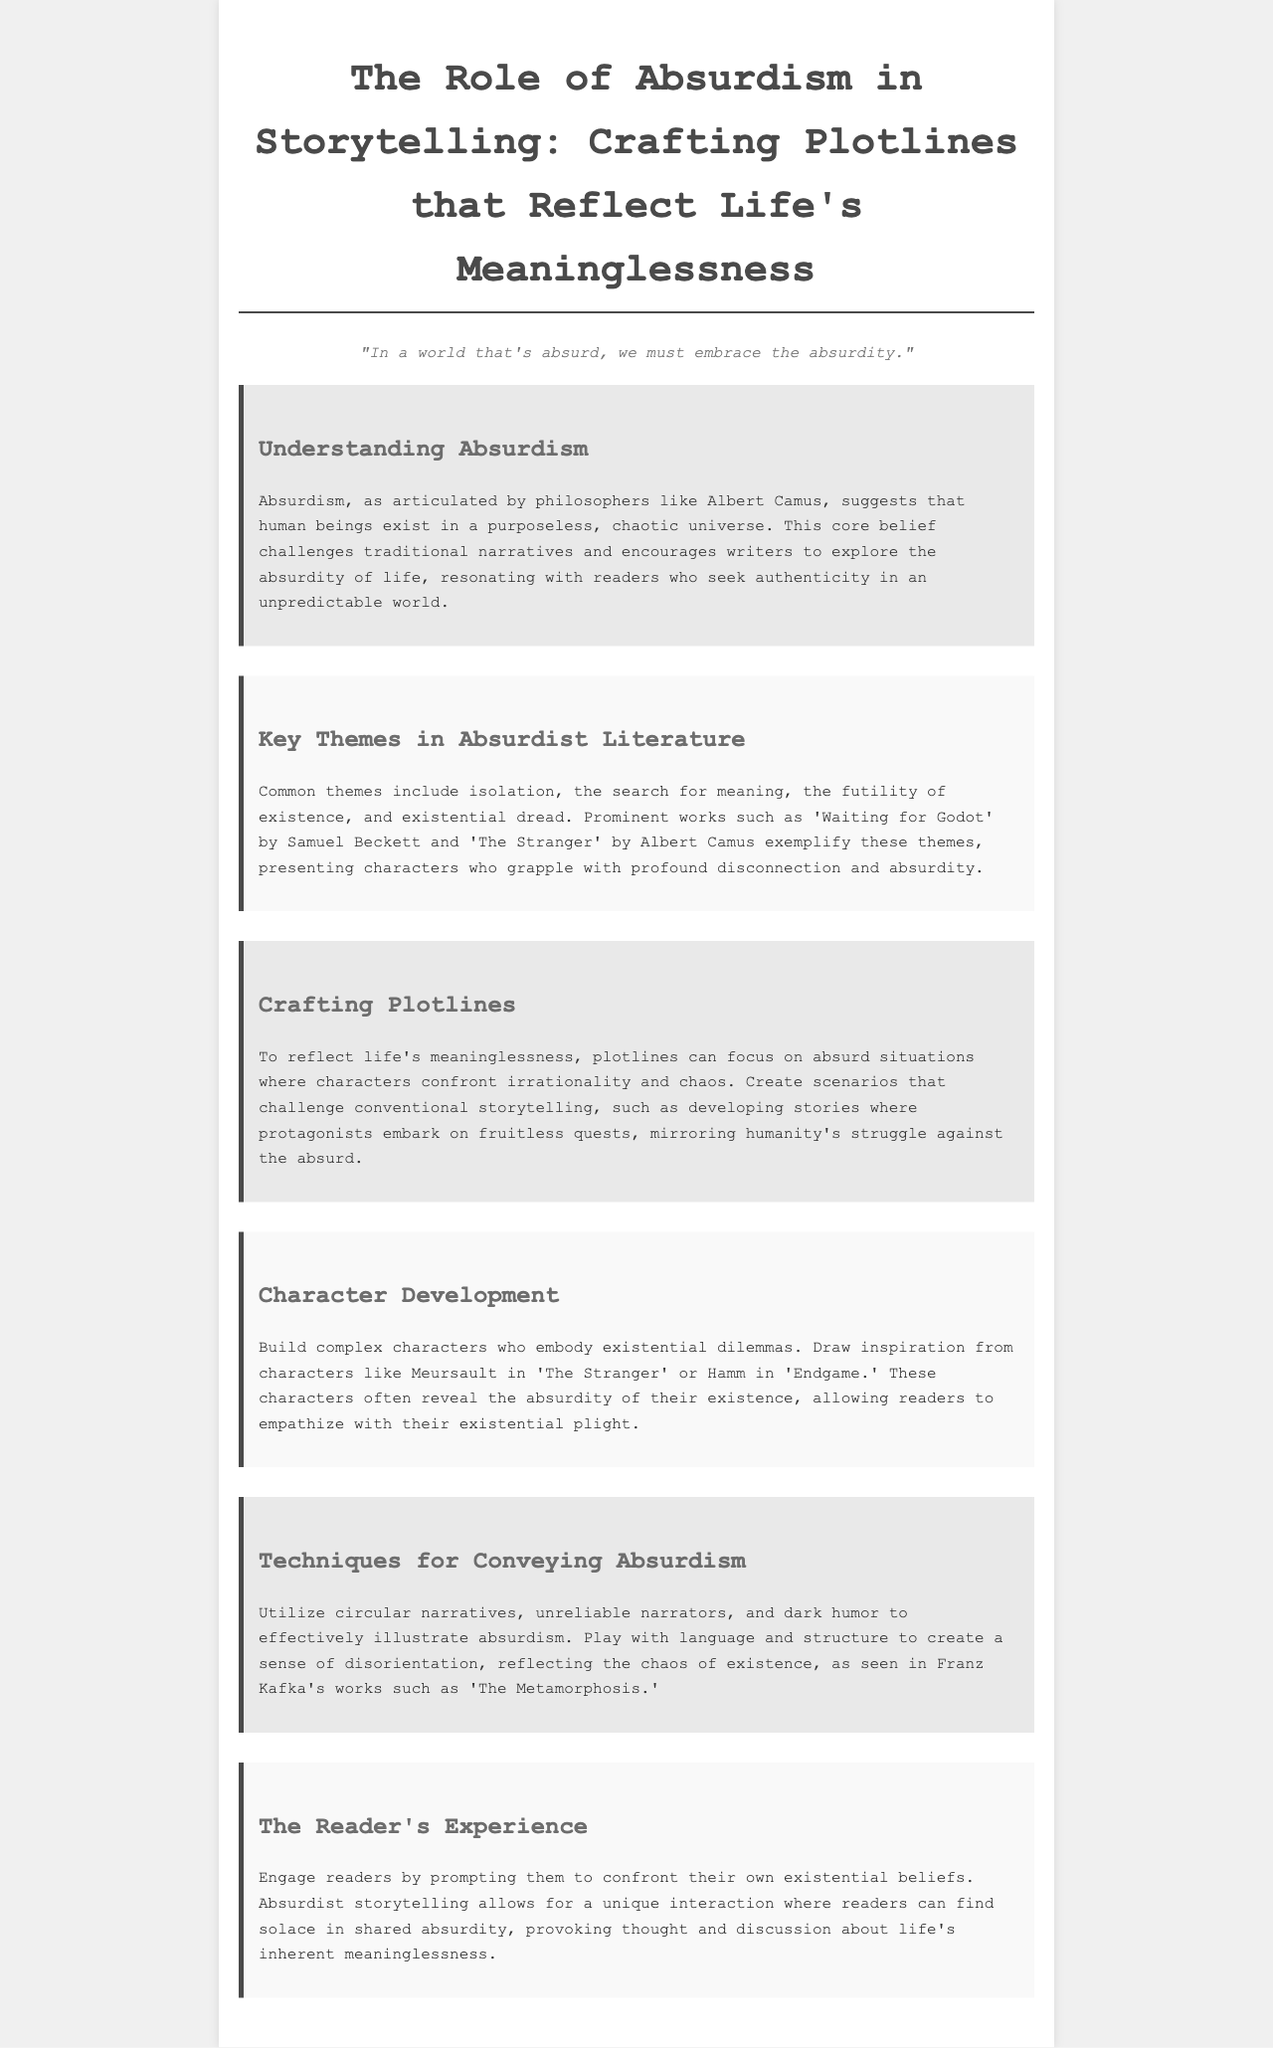What philosopher is associated with absurdism? The document mentions Albert Camus as a key philosopher associated with absurdism.
Answer: Albert Camus Name a prominent work that exemplifies absurdist themes. The brochure lists 'Waiting for Godot' as a prominent work exemplifying absurdist themes.
Answer: Waiting for Godot What is a common theme in absurdist literature? The document states that isolation is a common theme in absurdist literature.
Answer: Isolation What narrative technique can be used to convey absurdism? The brochure suggests using unreliable narrators as a technique to convey absurdism.
Answer: Unreliable narrators What character from 'The Stranger' is referenced? The document refers to Meursault as a character from 'The Stranger'.
Answer: Meursault How can plotlines reflect life's meaninglessness? The document states that plotlines should focus on absurd situations to reflect life's meaninglessness.
Answer: Absurd situations What does absurdist storytelling prompt readers to confront? The document mentions that absurdist storytelling prompts readers to confront their own existential beliefs.
Answer: Existential beliefs What emotion does dark humor convey in absurdist storytelling? The document implies that dark humor illustrates absurdism effectively.
Answer: Absurdism 